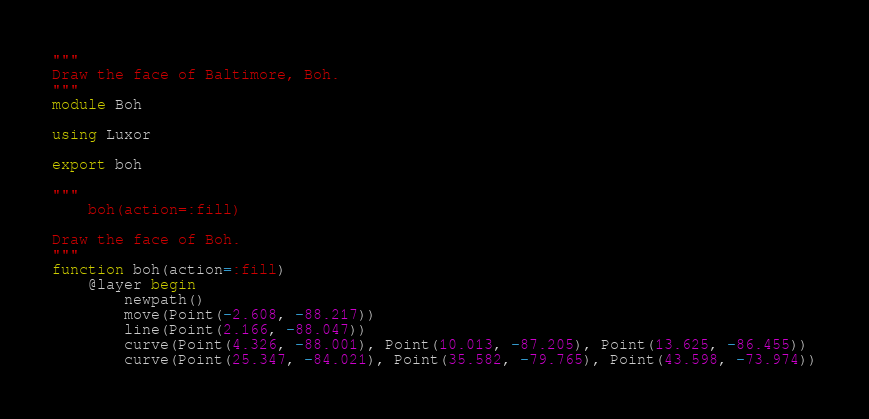<code> <loc_0><loc_0><loc_500><loc_500><_Julia_>"""
Draw the face of Baltimore, Boh.
"""
module Boh

using Luxor

export boh

"""
    boh(action=:fill)

Draw the face of Boh.
"""
function boh(action=:fill)
    @layer begin
        newpath()
        move(Point(-2.608, -88.217))
        line(Point(2.166, -88.047))
        curve(Point(4.326, -88.001), Point(10.013, -87.205), Point(13.625, -86.455))
        curve(Point(25.347, -84.021), Point(35.582, -79.765), Point(43.598, -73.974))</code> 